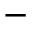<formula> <loc_0><loc_0><loc_500><loc_500>-</formula> 